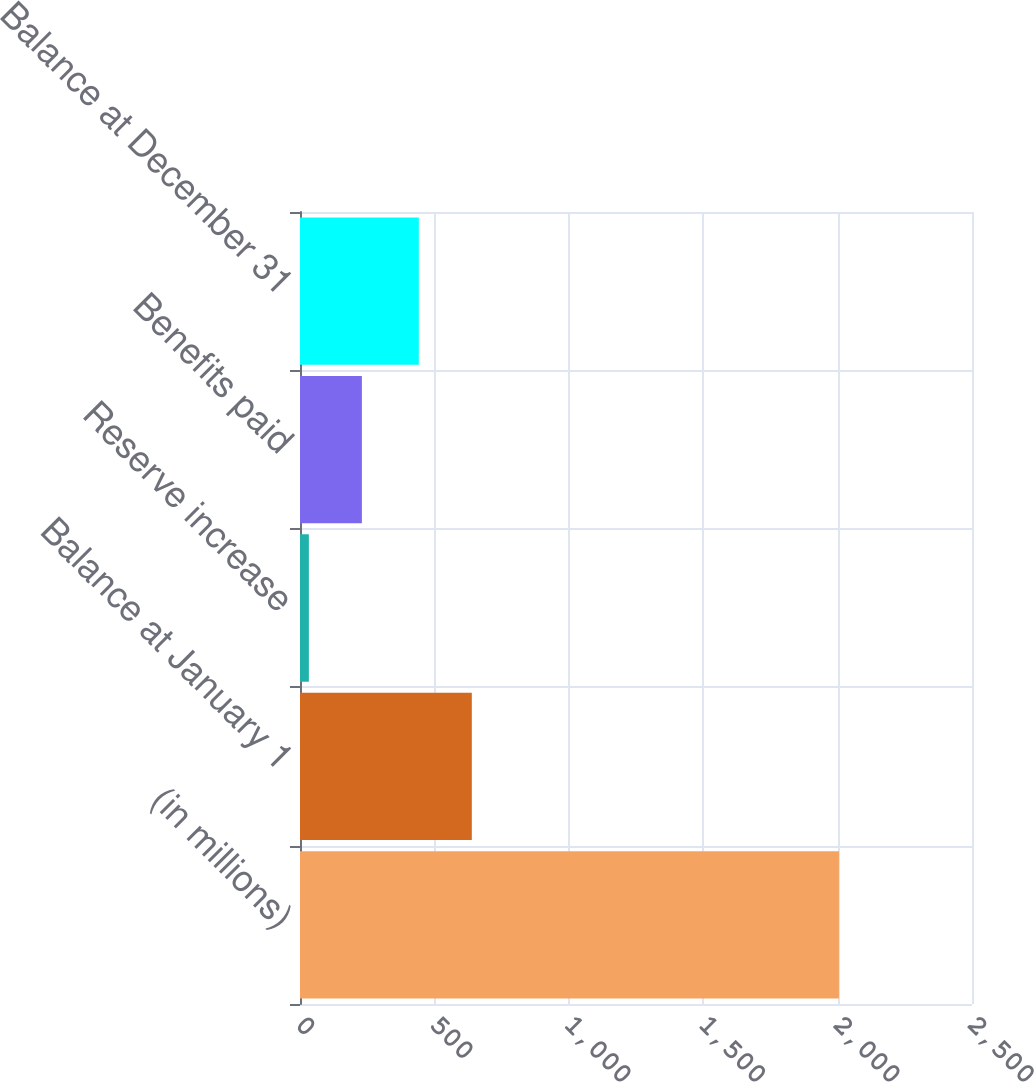Convert chart to OTSL. <chart><loc_0><loc_0><loc_500><loc_500><bar_chart><fcel>(in millions)<fcel>Balance at January 1<fcel>Reserve increase<fcel>Benefits paid<fcel>Balance at December 31<nl><fcel>2005<fcel>639.2<fcel>33<fcel>230.2<fcel>442<nl></chart> 